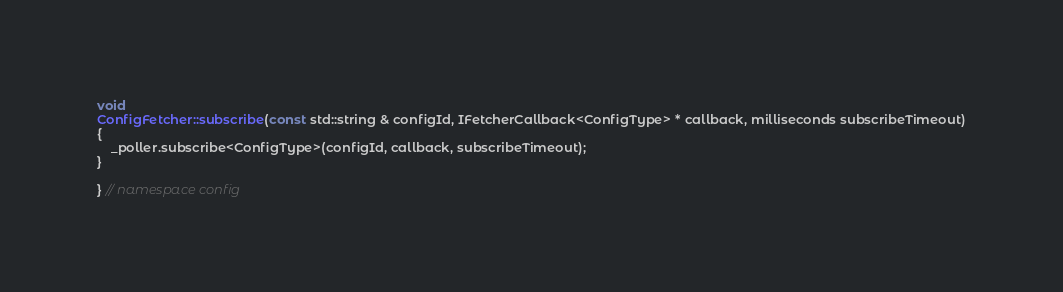Convert code to text. <code><loc_0><loc_0><loc_500><loc_500><_C++_>void
ConfigFetcher::subscribe(const std::string & configId, IFetcherCallback<ConfigType> * callback, milliseconds subscribeTimeout)
{
    _poller.subscribe<ConfigType>(configId, callback, subscribeTimeout);
}

} // namespace config
</code> 